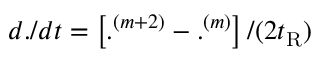<formula> <loc_0><loc_0><loc_500><loc_500>d . / d t = \left [ . ^ { ( m + 2 ) } - . ^ { ( m ) } \right ] / ( 2 t _ { R } )</formula> 